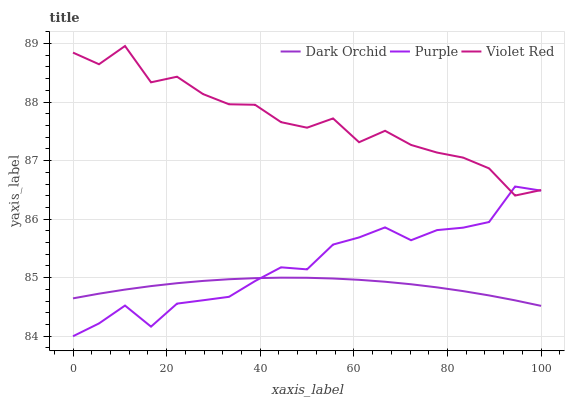Does Violet Red have the minimum area under the curve?
Answer yes or no. No. Does Dark Orchid have the maximum area under the curve?
Answer yes or no. No. Is Violet Red the smoothest?
Answer yes or no. No. Is Dark Orchid the roughest?
Answer yes or no. No. Does Dark Orchid have the lowest value?
Answer yes or no. No. Does Dark Orchid have the highest value?
Answer yes or no. No. Is Dark Orchid less than Violet Red?
Answer yes or no. Yes. Is Violet Red greater than Dark Orchid?
Answer yes or no. Yes. Does Dark Orchid intersect Violet Red?
Answer yes or no. No. 